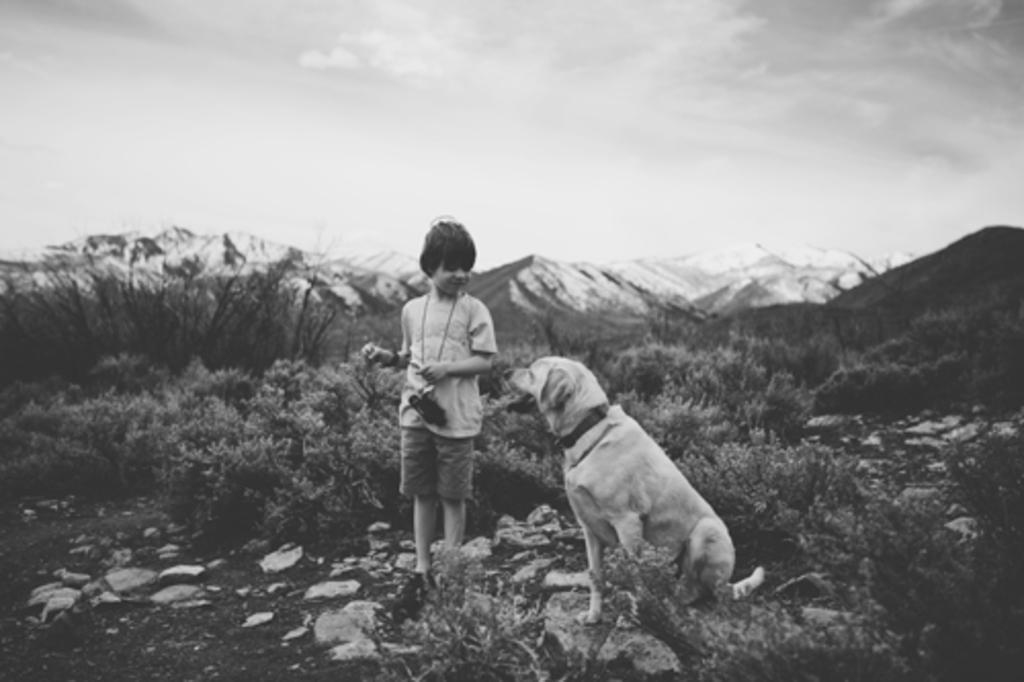How would you summarize this image in a sentence or two? This is a black and white image. I can see a boy standing. He wore a T-shirt, short and a camera to his neck. This is the dog sitting on the rock. I can see the plants and rocks. These are the mountains. 